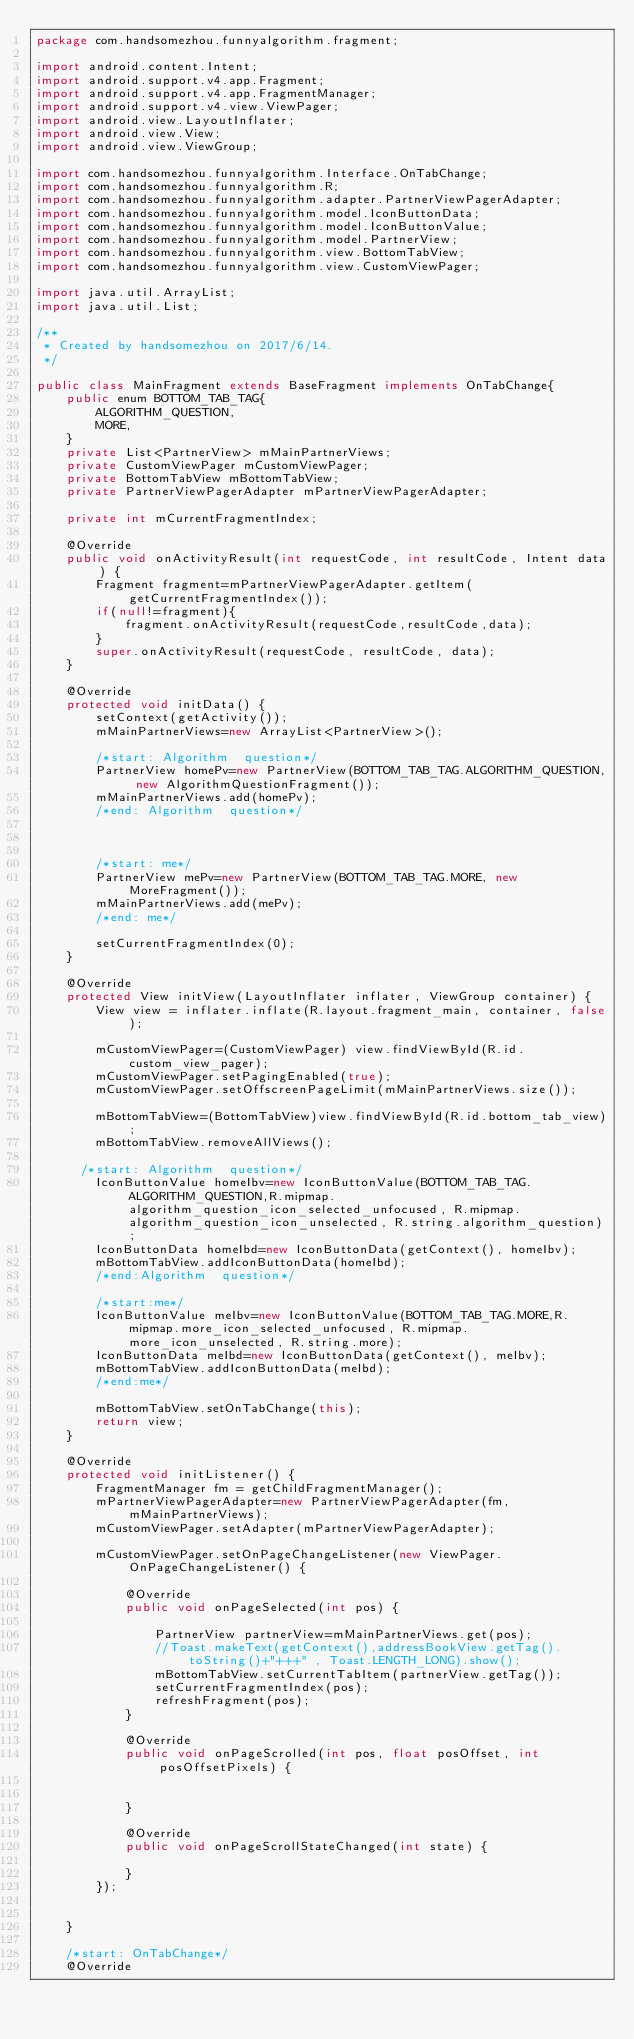Convert code to text. <code><loc_0><loc_0><loc_500><loc_500><_Java_>package com.handsomezhou.funnyalgorithm.fragment;

import android.content.Intent;
import android.support.v4.app.Fragment;
import android.support.v4.app.FragmentManager;
import android.support.v4.view.ViewPager;
import android.view.LayoutInflater;
import android.view.View;
import android.view.ViewGroup;

import com.handsomezhou.funnyalgorithm.Interface.OnTabChange;
import com.handsomezhou.funnyalgorithm.R;
import com.handsomezhou.funnyalgorithm.adapter.PartnerViewPagerAdapter;
import com.handsomezhou.funnyalgorithm.model.IconButtonData;
import com.handsomezhou.funnyalgorithm.model.IconButtonValue;
import com.handsomezhou.funnyalgorithm.model.PartnerView;
import com.handsomezhou.funnyalgorithm.view.BottomTabView;
import com.handsomezhou.funnyalgorithm.view.CustomViewPager;

import java.util.ArrayList;
import java.util.List;

/**
 * Created by handsomezhou on 2017/6/14.
 */

public class MainFragment extends BaseFragment implements OnTabChange{
    public enum BOTTOM_TAB_TAG{
        ALGORITHM_QUESTION,
        MORE,
    }
    private List<PartnerView> mMainPartnerViews;
    private CustomViewPager mCustomViewPager;
    private BottomTabView mBottomTabView;
    private PartnerViewPagerAdapter mPartnerViewPagerAdapter;

    private int mCurrentFragmentIndex;

    @Override
    public void onActivityResult(int requestCode, int resultCode, Intent data) {
        Fragment fragment=mPartnerViewPagerAdapter.getItem(getCurrentFragmentIndex());
        if(null!=fragment){
            fragment.onActivityResult(requestCode,resultCode,data);
        }
        super.onActivityResult(requestCode, resultCode, data);
    }

    @Override
    protected void initData() {
        setContext(getActivity());
        mMainPartnerViews=new ArrayList<PartnerView>();

		/*start: Algorithm  question*/
        PartnerView homePv=new PartnerView(BOTTOM_TAB_TAG.ALGORITHM_QUESTION, new AlgorithmQuestionFragment());
        mMainPartnerViews.add(homePv);
		/*end: Algorithm  question*/



		/*start: me*/
        PartnerView mePv=new PartnerView(BOTTOM_TAB_TAG.MORE, new MoreFragment());
        mMainPartnerViews.add(mePv);
		/*end: me*/

        setCurrentFragmentIndex(0);
    }

    @Override
    protected View initView(LayoutInflater inflater, ViewGroup container) {
        View view = inflater.inflate(R.layout.fragment_main, container, false);

        mCustomViewPager=(CustomViewPager) view.findViewById(R.id.custom_view_pager);
        mCustomViewPager.setPagingEnabled(true);
        mCustomViewPager.setOffscreenPageLimit(mMainPartnerViews.size());

        mBottomTabView=(BottomTabView)view.findViewById(R.id.bottom_tab_view);
        mBottomTabView.removeAllViews();

      /*start: Algorithm  question*/
        IconButtonValue homeIbv=new IconButtonValue(BOTTOM_TAB_TAG.ALGORITHM_QUESTION,R.mipmap.algorithm_question_icon_selected_unfocused, R.mipmap.algorithm_question_icon_unselected, R.string.algorithm_question);
        IconButtonData homeIbd=new IconButtonData(getContext(), homeIbv);
        mBottomTabView.addIconButtonData(homeIbd);
		/*end:Algorithm  question*/

        /*start:me*/
        IconButtonValue meIbv=new IconButtonValue(BOTTOM_TAB_TAG.MORE,R.mipmap.more_icon_selected_unfocused, R.mipmap.more_icon_unselected, R.string.more);
        IconButtonData meIbd=new IconButtonData(getContext(), meIbv);
        mBottomTabView.addIconButtonData(meIbd);
		/*end:me*/

        mBottomTabView.setOnTabChange(this);
        return view;
    }

    @Override
    protected void initListener() {
        FragmentManager fm = getChildFragmentManager();
        mPartnerViewPagerAdapter=new PartnerViewPagerAdapter(fm, mMainPartnerViews);
        mCustomViewPager.setAdapter(mPartnerViewPagerAdapter);

        mCustomViewPager.setOnPageChangeListener(new ViewPager.OnPageChangeListener() {

            @Override
            public void onPageSelected(int pos) {

                PartnerView partnerView=mMainPartnerViews.get(pos);
                //Toast.makeText(getContext(),addressBookView.getTag().toString()+"+++" , Toast.LENGTH_LONG).show();
                mBottomTabView.setCurrentTabItem(partnerView.getTag());
                setCurrentFragmentIndex(pos);
                refreshFragment(pos);
            }

            @Override
            public void onPageScrolled(int pos, float posOffset, int posOffsetPixels) {


            }

            @Override
            public void onPageScrollStateChanged(int state) {

            }
        });


    }

    /*start: OnTabChange*/
    @Override</code> 